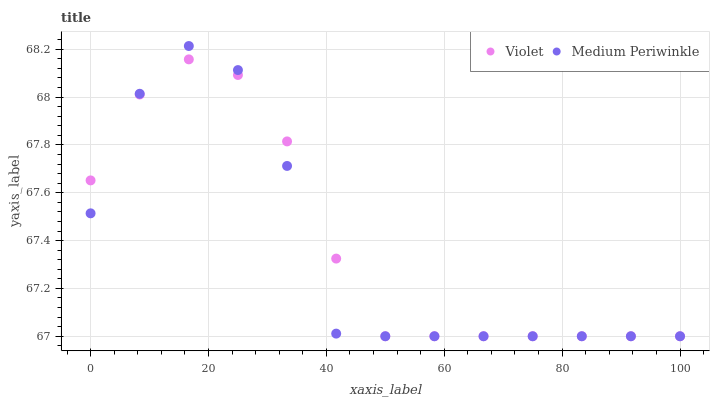Does Medium Periwinkle have the minimum area under the curve?
Answer yes or no. Yes. Does Violet have the maximum area under the curve?
Answer yes or no. Yes. Does Violet have the minimum area under the curve?
Answer yes or no. No. Is Violet the smoothest?
Answer yes or no. Yes. Is Medium Periwinkle the roughest?
Answer yes or no. Yes. Is Violet the roughest?
Answer yes or no. No. Does Medium Periwinkle have the lowest value?
Answer yes or no. Yes. Does Medium Periwinkle have the highest value?
Answer yes or no. Yes. Does Violet have the highest value?
Answer yes or no. No. Does Violet intersect Medium Periwinkle?
Answer yes or no. Yes. Is Violet less than Medium Periwinkle?
Answer yes or no. No. Is Violet greater than Medium Periwinkle?
Answer yes or no. No. 